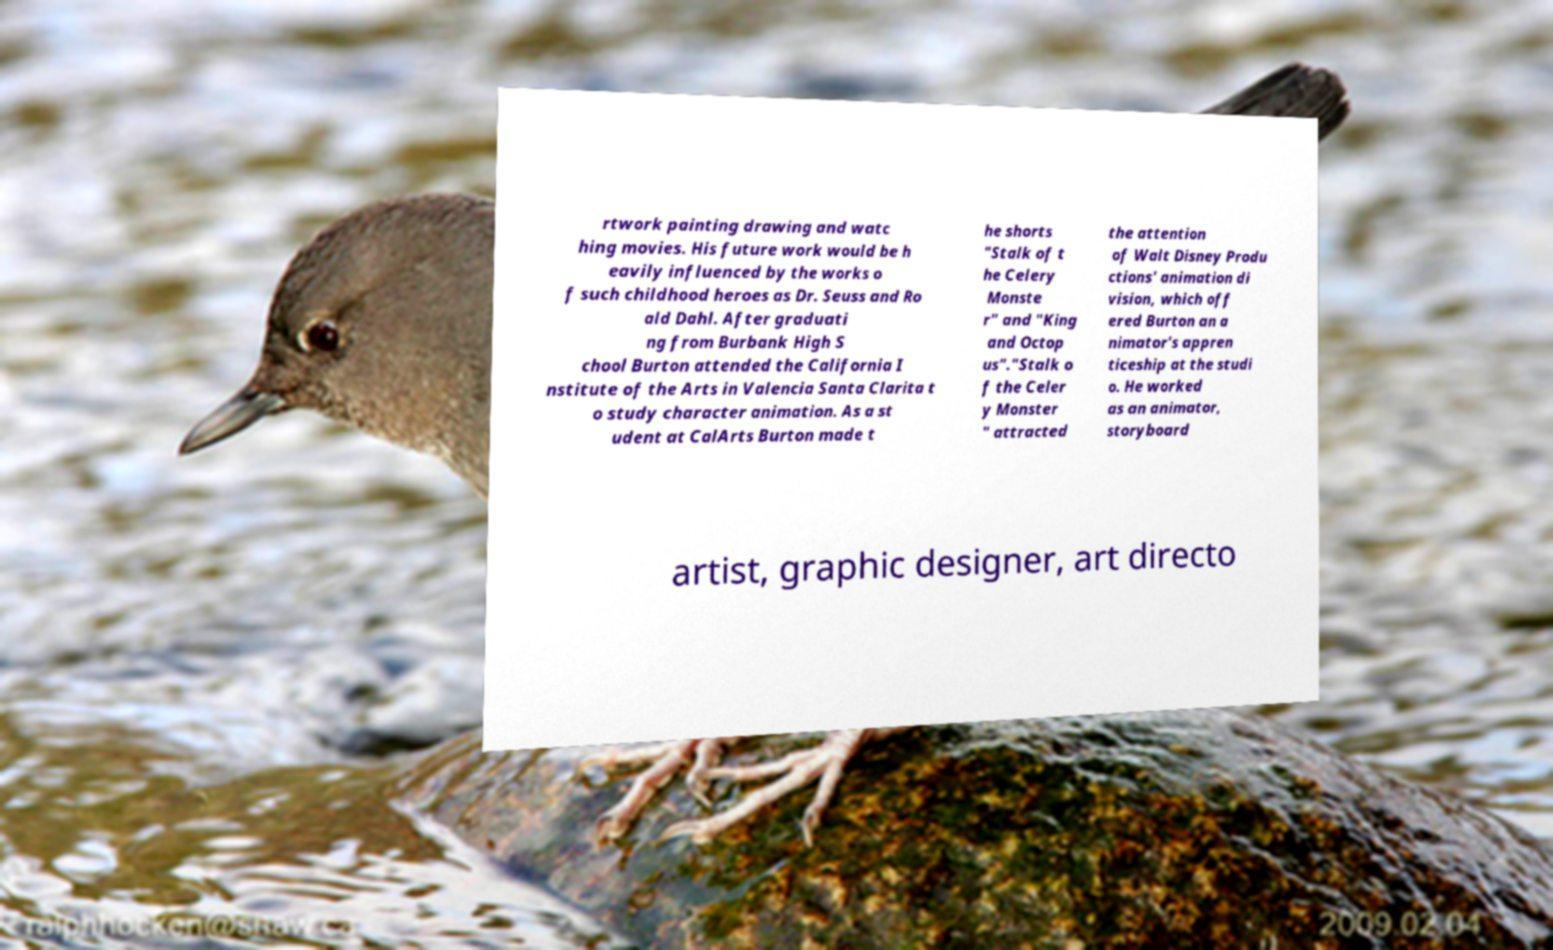Can you read and provide the text displayed in the image?This photo seems to have some interesting text. Can you extract and type it out for me? rtwork painting drawing and watc hing movies. His future work would be h eavily influenced by the works o f such childhood heroes as Dr. Seuss and Ro ald Dahl. After graduati ng from Burbank High S chool Burton attended the California I nstitute of the Arts in Valencia Santa Clarita t o study character animation. As a st udent at CalArts Burton made t he shorts "Stalk of t he Celery Monste r" and "King and Octop us"."Stalk o f the Celer y Monster " attracted the attention of Walt Disney Produ ctions' animation di vision, which off ered Burton an a nimator's appren ticeship at the studi o. He worked as an animator, storyboard artist, graphic designer, art directo 